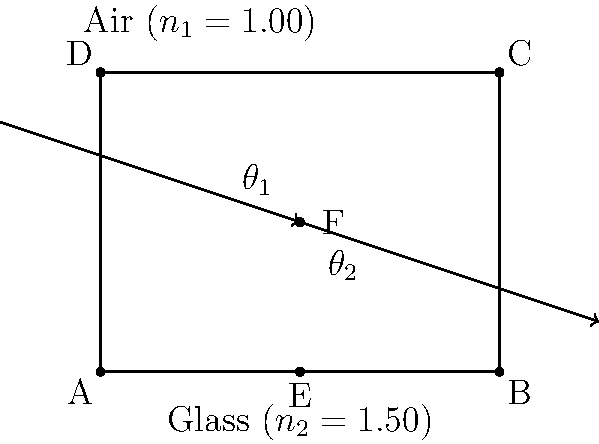A transparent glass art installation in the shape of a rectangular prism is being considered for a public space. Light enters the installation at an angle of 45° to the normal. If the refractive index of the glass is 1.50, what is the angle of refraction inside the glass? (Assume the refractive index of air is 1.00) To solve this problem, we'll use Snell's law, which describes the relationship between the angles of incidence and refraction for light passing through different media:

$$n_1 \sin(\theta_1) = n_2 \sin(\theta_2)$$

Where:
$n_1$ = refractive index of medium 1 (air)
$n_2$ = refractive index of medium 2 (glass)
$\theta_1$ = angle of incidence
$\theta_2$ = angle of refraction

Given:
$n_1 = 1.00$ (air)
$n_2 = 1.50$ (glass)
$\theta_1 = 45°$

Step 1: Substitute the known values into Snell's law:
$$(1.00) \sin(45°) = (1.50) \sin(\theta_2)$$

Step 2: Simplify the left side of the equation:
$$\frac{\sqrt{2}}{2} = 1.50 \sin(\theta_2)$$

Step 3: Solve for $\sin(\theta_2)$:
$$\sin(\theta_2) = \frac{\sqrt{2}}{2 \cdot 1.50} = \frac{\sqrt{2}}{3}$$

Step 4: Take the inverse sine (arcsin) of both sides to find $\theta_2$:
$$\theta_2 = \arcsin\left(\frac{\sqrt{2}}{3}\right)$$

Step 5: Calculate the result:
$$\theta_2 \approx 28.1°$$

Therefore, the angle of refraction inside the glass art installation is approximately 28.1°.
Answer: 28.1° 